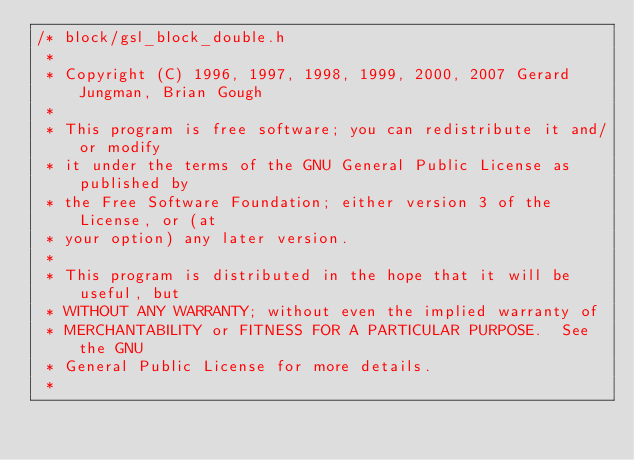Convert code to text. <code><loc_0><loc_0><loc_500><loc_500><_C_>/* block/gsl_block_double.h
 * 
 * Copyright (C) 1996, 1997, 1998, 1999, 2000, 2007 Gerard Jungman, Brian Gough
 * 
 * This program is free software; you can redistribute it and/or modify
 * it under the terms of the GNU General Public License as published by
 * the Free Software Foundation; either version 3 of the License, or (at
 * your option) any later version.
 * 
 * This program is distributed in the hope that it will be useful, but
 * WITHOUT ANY WARRANTY; without even the implied warranty of
 * MERCHANTABILITY or FITNESS FOR A PARTICULAR PURPOSE.  See the GNU
 * General Public License for more details.
 * </code> 